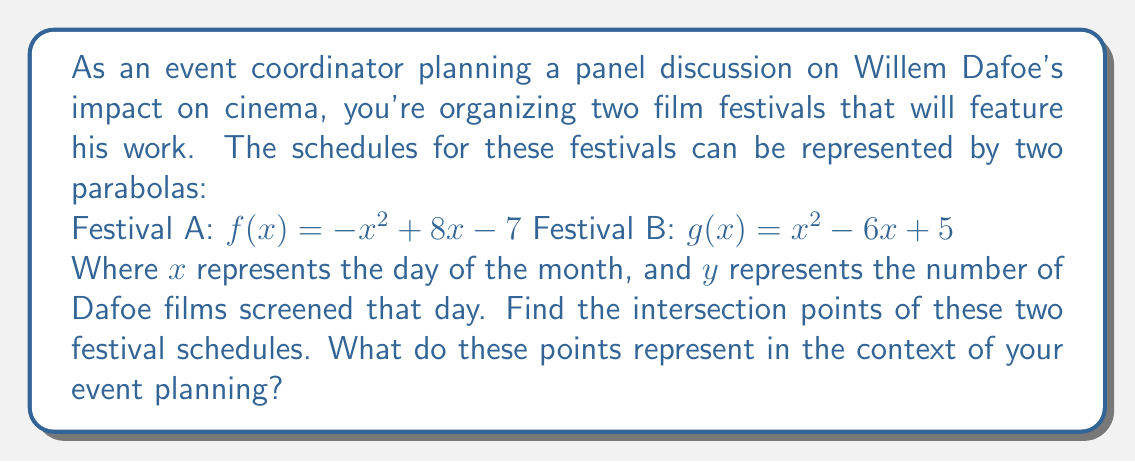Can you answer this question? To find the intersection points of the two parabolas, we need to solve the equation $f(x) = g(x)$:

1) Set up the equation:
   $-x^2 + 8x - 7 = x^2 - 6x + 5$

2) Rearrange the equation to standard form:
   $-x^2 + 8x - 7 - (x^2 - 6x + 5) = 0$
   $-2x^2 + 14x - 12 = 0$

3) Divide everything by -2 to simplify:
   $x^2 - 7x + 6 = 0$

4) This is a quadratic equation. We can solve it using the quadratic formula:
   $x = \frac{-b \pm \sqrt{b^2 - 4ac}}{2a}$

   Where $a = 1$, $b = -7$, and $c = 6$

5) Plugging into the quadratic formula:
   $x = \frac{7 \pm \sqrt{(-7)^2 - 4(1)(6)}}{2(1)}$
   $x = \frac{7 \pm \sqrt{49 - 24}}{2}$
   $x = \frac{7 \pm \sqrt{25}}{2}$
   $x = \frac{7 \pm 5}{2}$

6) This gives us two solutions:
   $x_1 = \frac{7 + 5}{2} = 6$
   $x_2 = \frac{7 - 5}{2} = 1$

7) To find the y-coordinates, we can plug these x-values into either of the original functions:

   For $x = 6$:
   $f(6) = -(6)^2 + 8(6) - 7 = -36 + 48 - 7 = 5$

   For $x = 1$:
   $f(1) = -(1)^2 + 8(1) - 7 = -1 + 8 - 7 = 0$

Therefore, the intersection points are (6, 5) and (1, 0).

In the context of event planning, these points represent:
1) On day 1 of the month, both festivals are starting and not showing any Dafoe films.
2) On day 6 of the month, both festivals are showing 5 Dafoe films.

These could be strategic days for scheduling your panel discussion on Willem Dafoe's impact on cinema.
Answer: The intersection points are (6, 5) and (1, 0). 